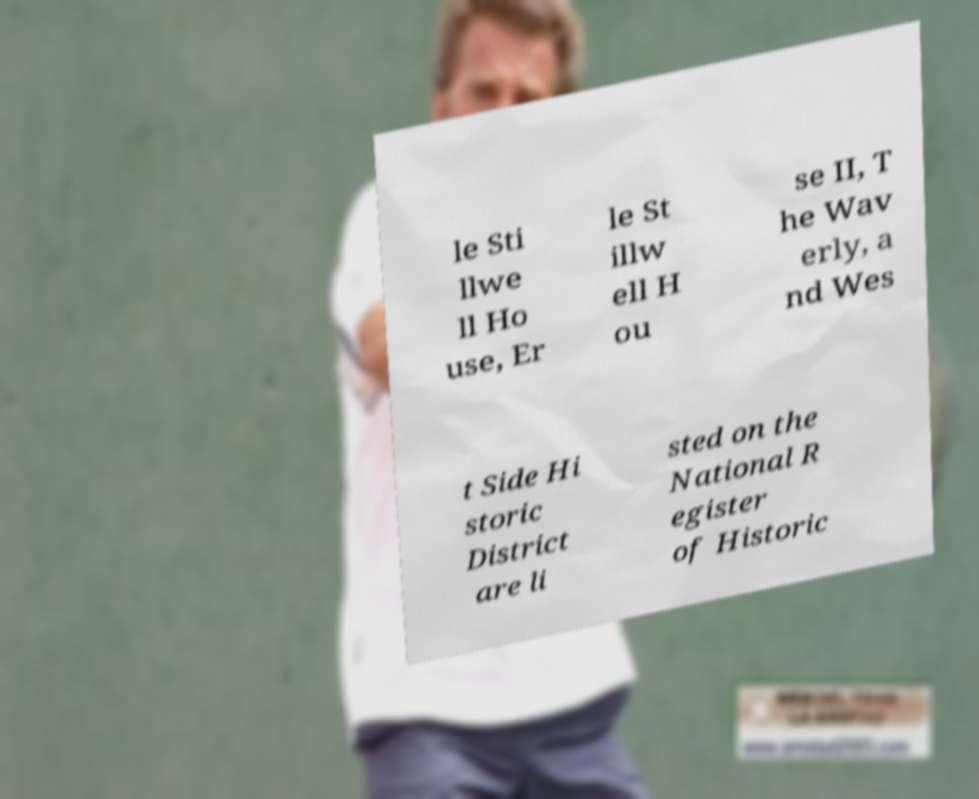Could you assist in decoding the text presented in this image and type it out clearly? le Sti llwe ll Ho use, Er le St illw ell H ou se II, T he Wav erly, a nd Wes t Side Hi storic District are li sted on the National R egister of Historic 